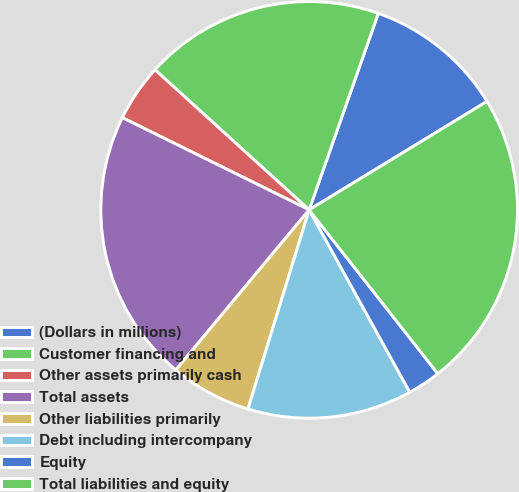Convert chart to OTSL. <chart><loc_0><loc_0><loc_500><loc_500><pie_chart><fcel>(Dollars in millions)<fcel>Customer financing and<fcel>Other assets primarily cash<fcel>Total assets<fcel>Other liabilities primarily<fcel>Debt including intercompany<fcel>Equity<fcel>Total liabilities and equity<nl><fcel>10.9%<fcel>18.65%<fcel>4.44%<fcel>21.25%<fcel>6.31%<fcel>12.77%<fcel>2.57%<fcel>23.12%<nl></chart> 